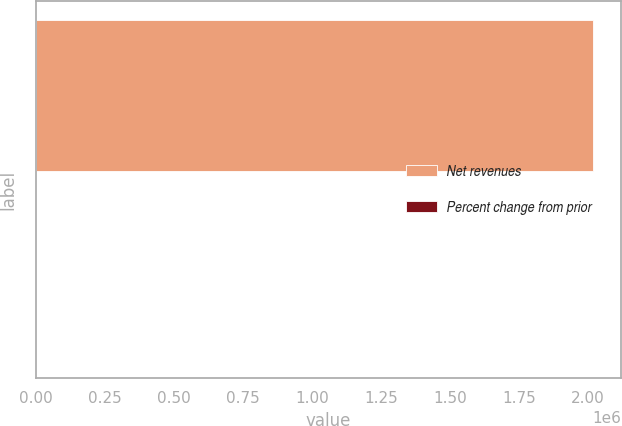<chart> <loc_0><loc_0><loc_500><loc_500><bar_chart><fcel>Net revenues<fcel>Percent change from prior<nl><fcel>2.02059e+06<fcel>1<nl></chart> 